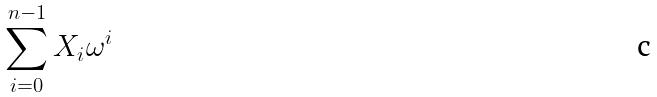Convert formula to latex. <formula><loc_0><loc_0><loc_500><loc_500>\sum _ { i = 0 } ^ { n - 1 } X _ { i } \omega ^ { i }</formula> 